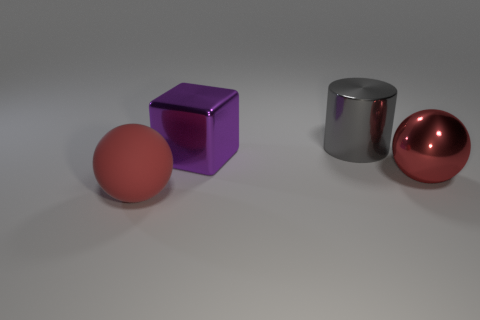What is the size of the other red object that is the same shape as the big rubber thing? The other red object, which is a sphere, appears to be significantly smaller than the larger cylindrical rubber object. It's difficult to provide an exact measurement without a reference scale, but it can be described as a medium-sized object relative to the other shapes in the image. 